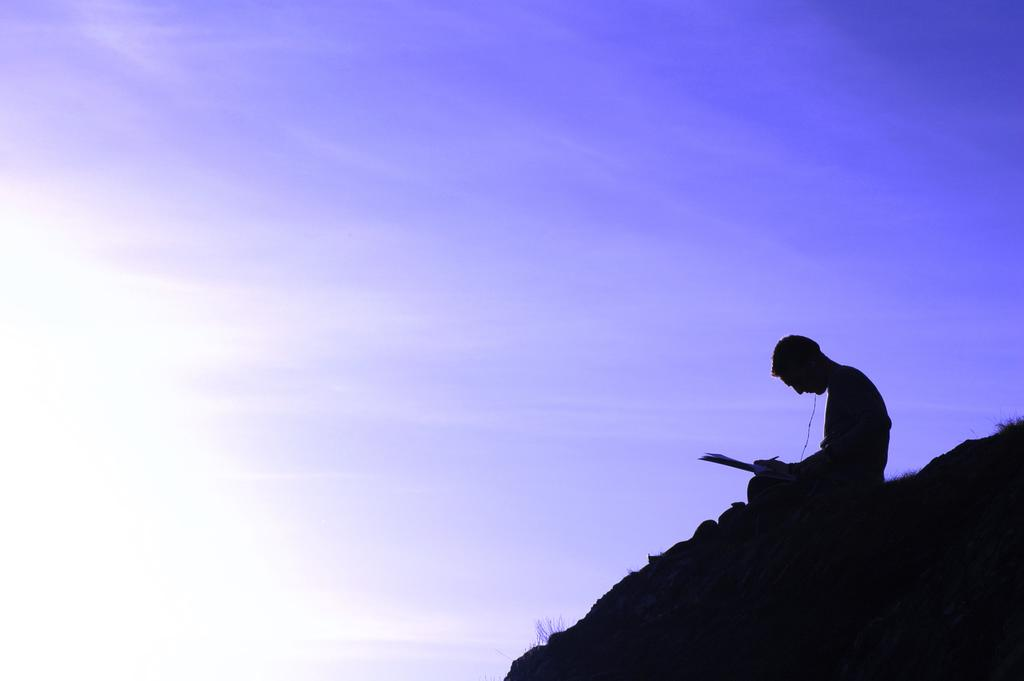Who is the main subject in the image? There is a boy in the image. Where is the boy located in the image? The boy is on the right side of the image. What is the boy doing in the image? The boy appears to be writing. What can be seen at the top of the image? The sky is visible at the top of the image. What type of rail does the boy want to ride in the image? There is no rail present in the image, and the boy's desires are not mentioned. Can you see any fairies flying around the boy in the image? There are no fairies present in the image. 